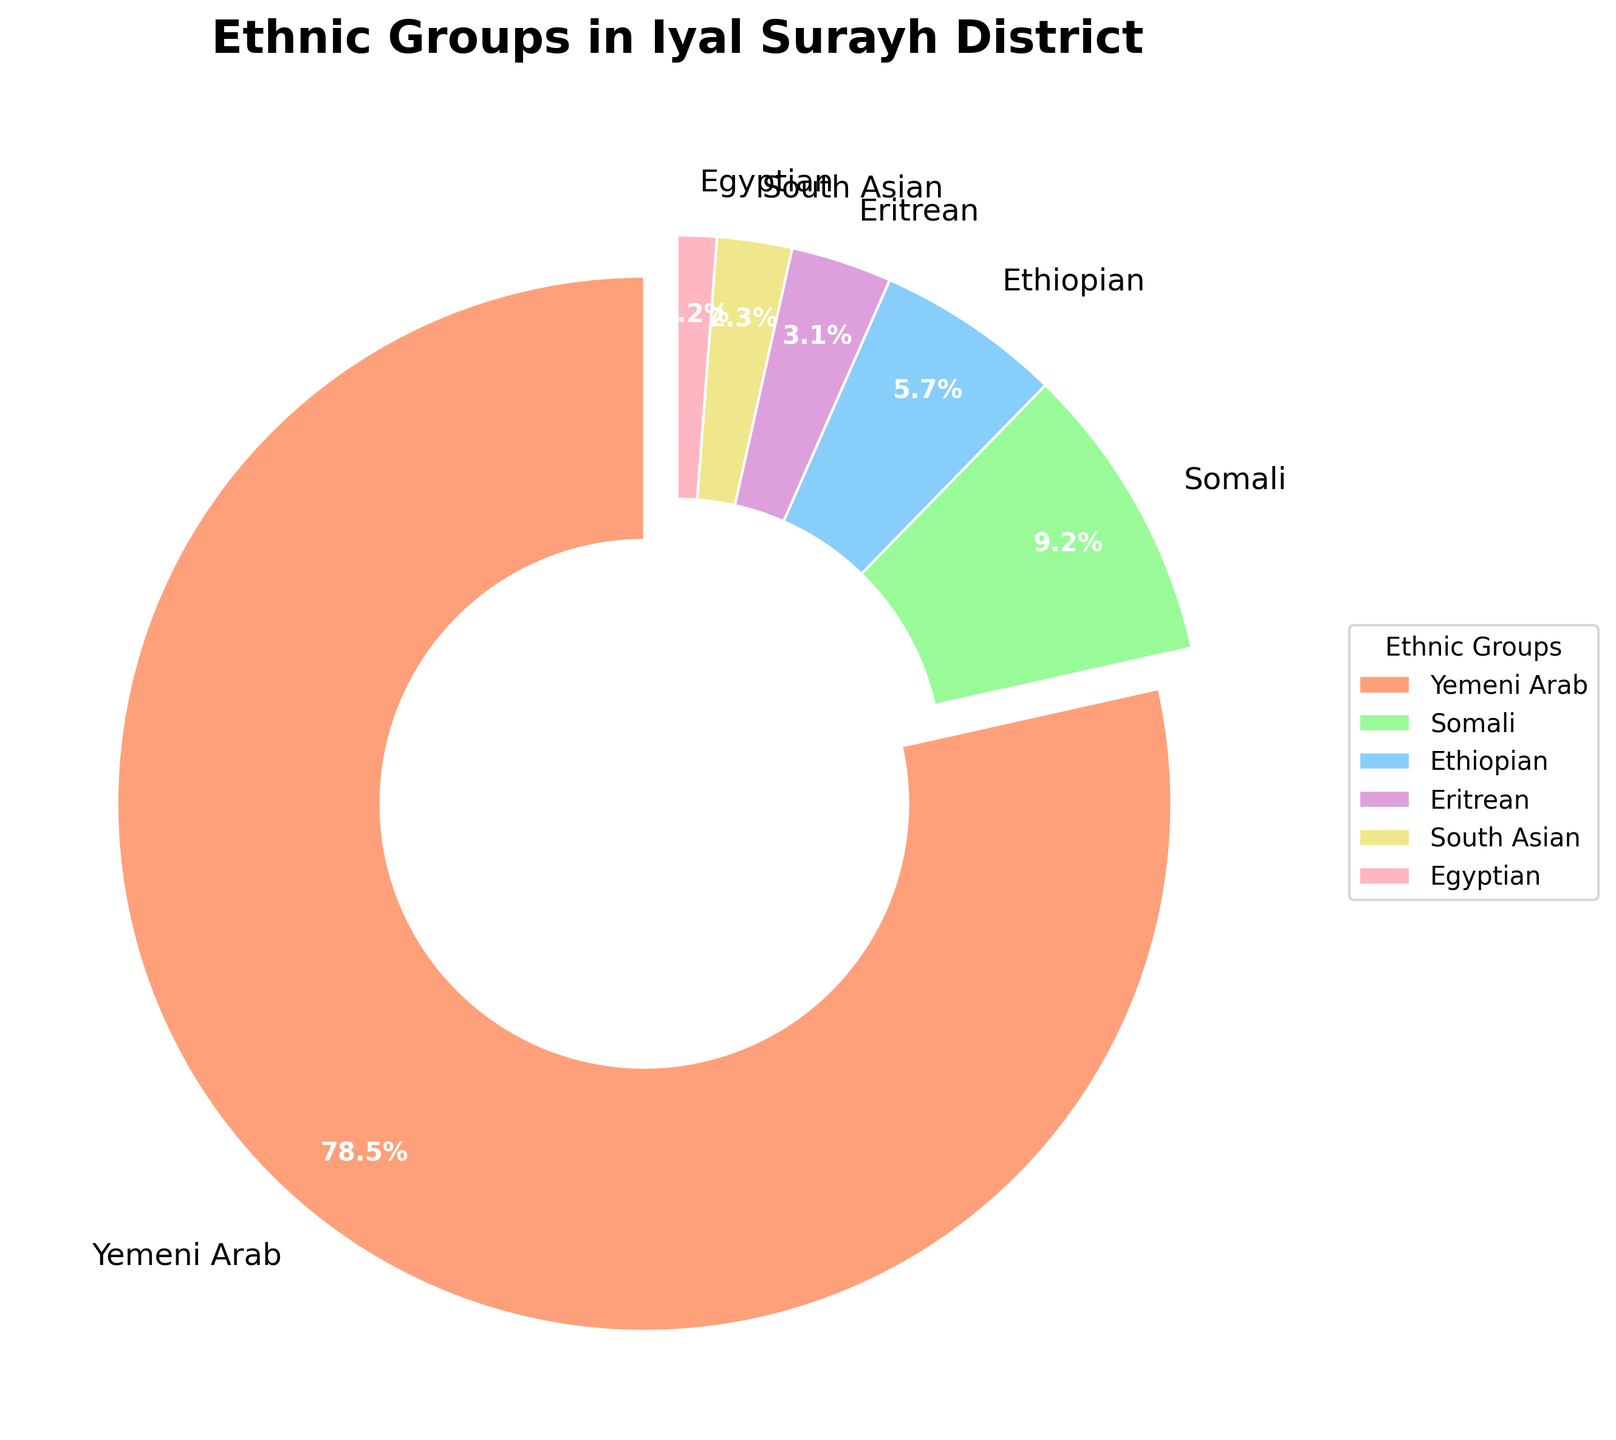What is the percentage of Yemeni Arabs in Iyal Surayh District? The Yemeni Arabs slice is labeled with its percentage. By looking at the slice labeled "Yemeni Arab" within the pie chart, we can see the percentage.
Answer: 78.5% Which ethnic group has the smallest percentage in Iyal Surayh District? By examining the pie chart, the smallest slice represents the ethnic group with the smallest percentage. The smallest slice is labeled "Egyptian".
Answer: Egyptian What is the combined percentage of Somali and Ethiopian groups? To find the combined percentage, add the percentages of the Somali and Ethiopian groups: 9.2% + 5.7%.
Answer: 14.9% How does the percentage of Eritrean compare to South Asian in the Iyal Surayh District? By comparing the sizes of the slices, the Eritrean percentage (3.1%) is greater than the South Asian percentage (2.3%).
Answer: Eritrean > South Asian What is the percentage difference between the largest and the smallest ethnic groups? The largest ethnic group is Yemeni Arab (78.5%) and the smallest is Egyptian (1.2%). Subtracting the smallest percentage from the largest gives 78.5% - 1.2%.
Answer: 77.3% Which color represents the Yemeni Arab group in the pie chart? Looking at the pie chart, each slice is colored differently. The slice labeled "Yemeni Arab" is represented by a unique color.
Answer: Light salmon (approximating #FFA07A) What is the average percentage across all ethnic groups? Calculate the average by summing all percentages and dividing by the number of groups: (78.5 + 9.2 + 5.7 + 3.1 + 2.3 + 1.2) / 6.
Answer: 16.67% How many ethnic groups have a percentage above 5%? By identifying slices with percentages above 5%, they are Yemeni Arab (78.5%), Somali (9.2%), and Ethiopian (5.7%). This counts as three groups.
Answer: 3 If you combine the percentage of Eritrean and South Asian groups, which other group will it be closest to? Adding the percentages of Eritrean (3.1%) and South Asian (2.3%) gives 5.4%. The closest percentage to 5.4% is Ethiopian at 5.7%.
Answer: Ethiopian 